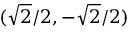Convert formula to latex. <formula><loc_0><loc_0><loc_500><loc_500>( { \sqrt { 2 } } / 2 , - { \sqrt { 2 } } / 2 )</formula> 